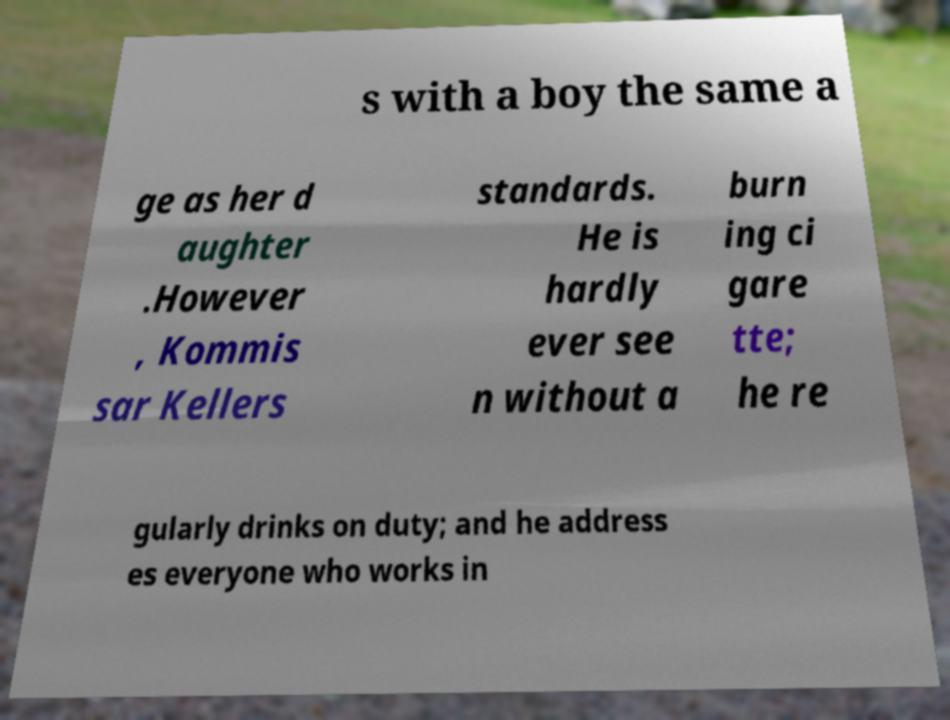For documentation purposes, I need the text within this image transcribed. Could you provide that? s with a boy the same a ge as her d aughter .However , Kommis sar Kellers standards. He is hardly ever see n without a burn ing ci gare tte; he re gularly drinks on duty; and he address es everyone who works in 